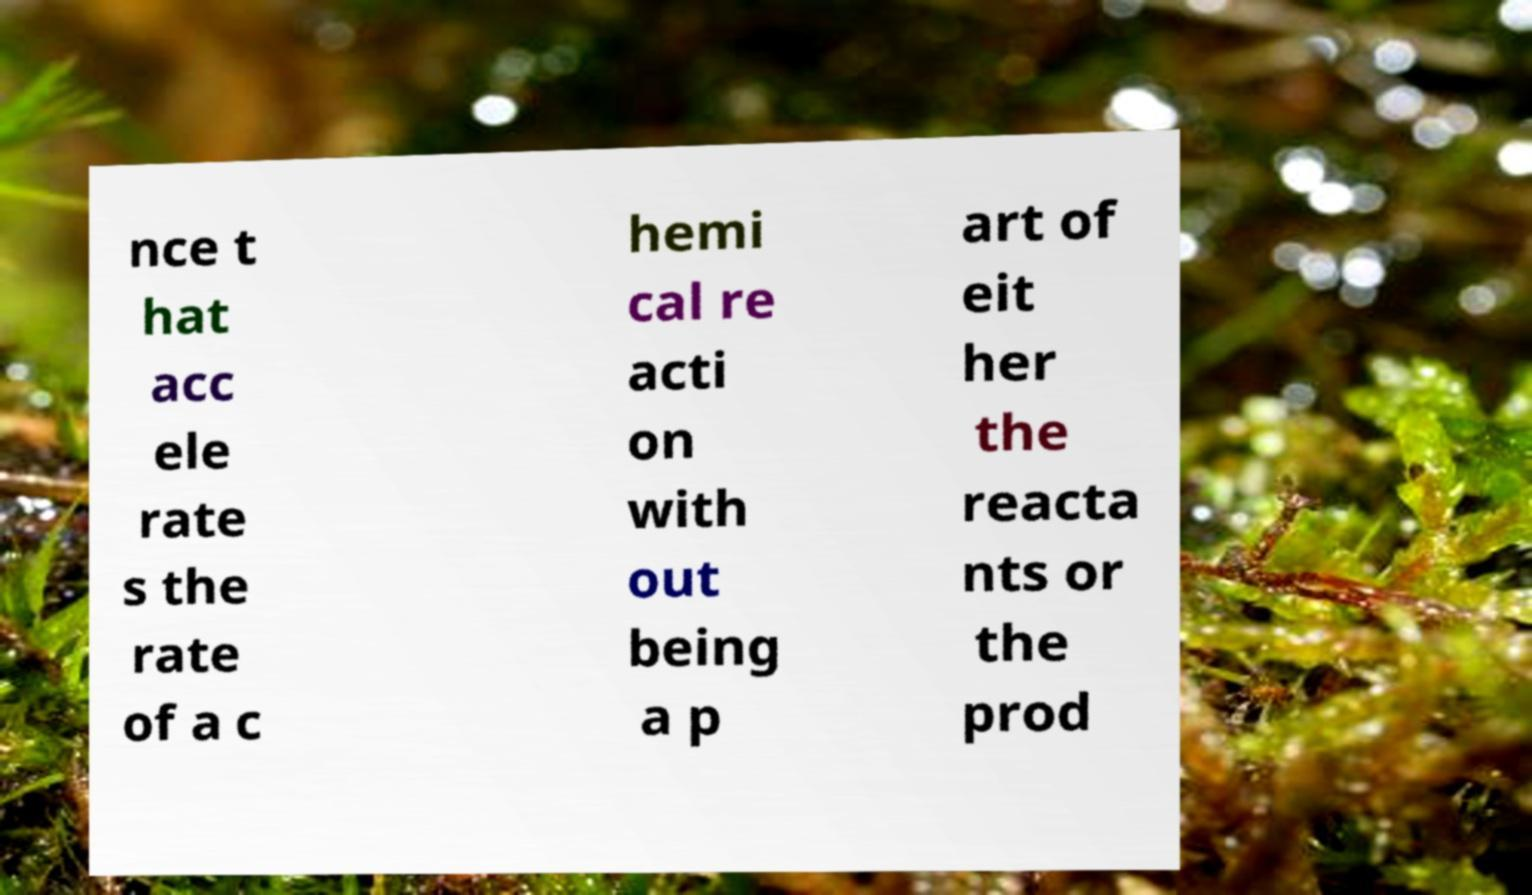Please identify and transcribe the text found in this image. nce t hat acc ele rate s the rate of a c hemi cal re acti on with out being a p art of eit her the reacta nts or the prod 